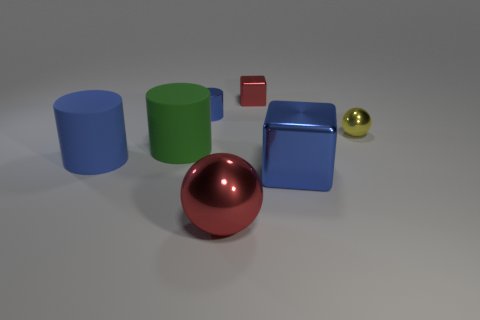How many large objects are either brown matte cylinders or red metallic blocks?
Your answer should be very brief. 0. What is the material of the large object that is the same color as the big metallic block?
Give a very brief answer. Rubber. Is the blue cylinder that is behind the tiny yellow metal thing made of the same material as the red thing that is behind the yellow metallic ball?
Make the answer very short. Yes. Are there any big blue metal things?
Offer a terse response. Yes. Is the number of green matte objects in front of the tiny blue metallic thing greater than the number of cubes that are to the left of the red shiny block?
Keep it short and to the point. Yes. What is the material of the other big thing that is the same shape as the green object?
Make the answer very short. Rubber. Is the color of the block that is on the left side of the blue block the same as the ball that is in front of the green thing?
Your answer should be compact. Yes. What shape is the yellow object?
Keep it short and to the point. Sphere. Are there more blue objects on the right side of the big metal ball than big gray matte cylinders?
Keep it short and to the point. Yes. There is a large thing in front of the large blue shiny thing; what is its shape?
Make the answer very short. Sphere. 